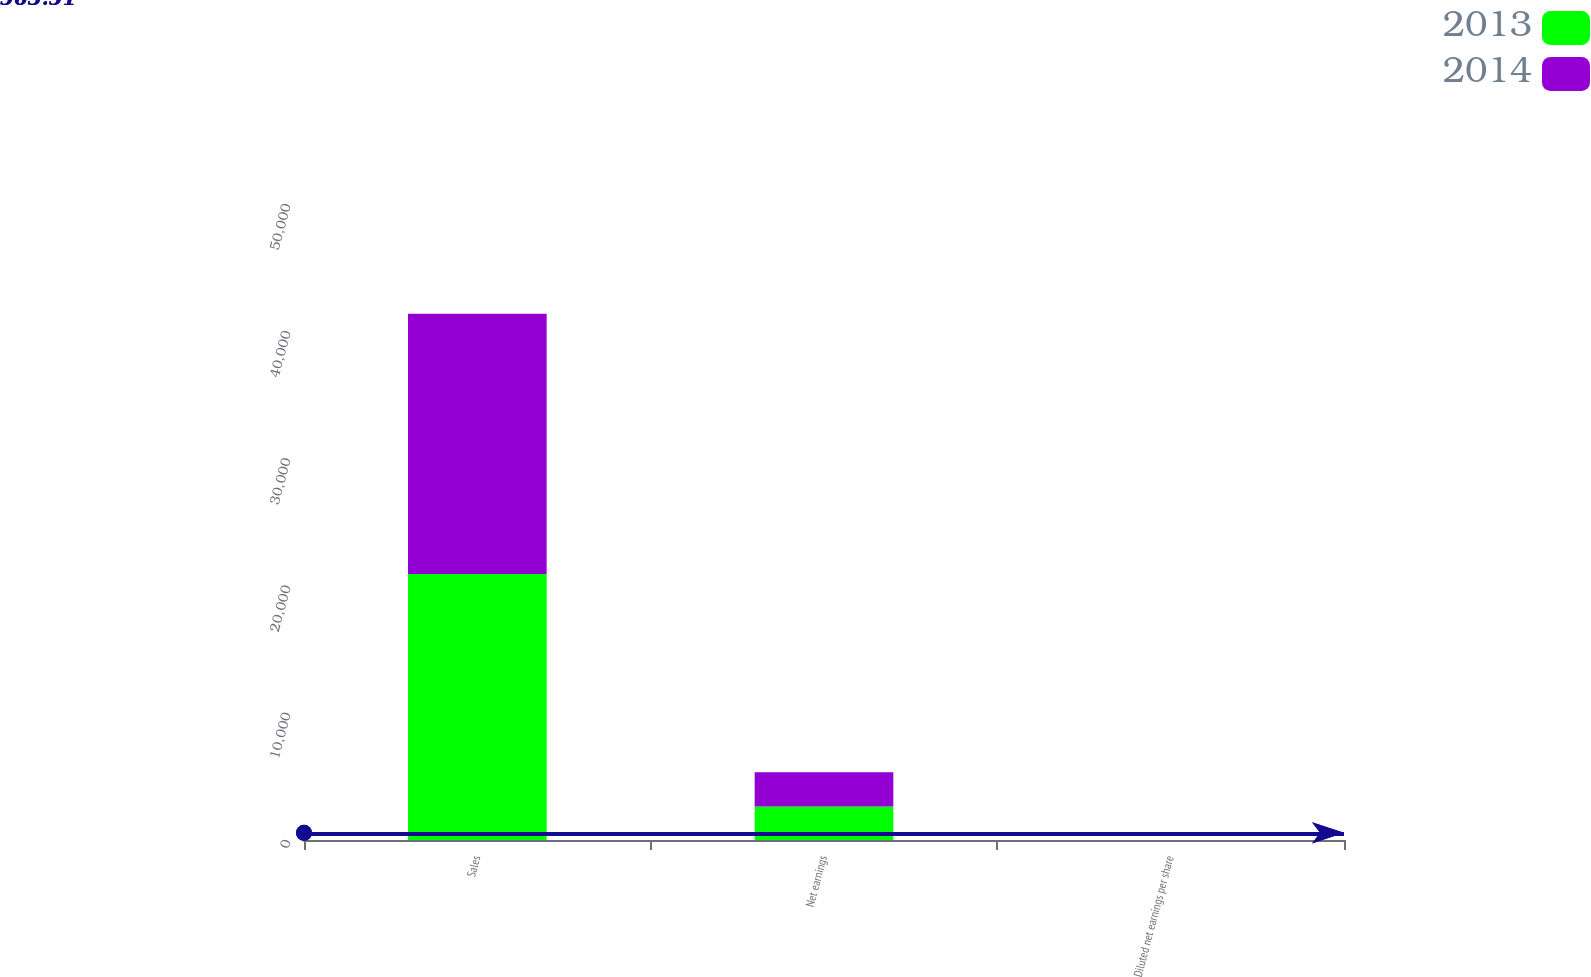Convert chart. <chart><loc_0><loc_0><loc_500><loc_500><stacked_bar_chart><ecel><fcel>Sales<fcel>Net earnings<fcel>Diluted net earnings per share<nl><fcel>2013<fcel>20911.2<fcel>2632.3<fcel>3.68<nl><fcel>2014<fcel>20459.2<fcel>2689.9<fcel>3.79<nl></chart> 